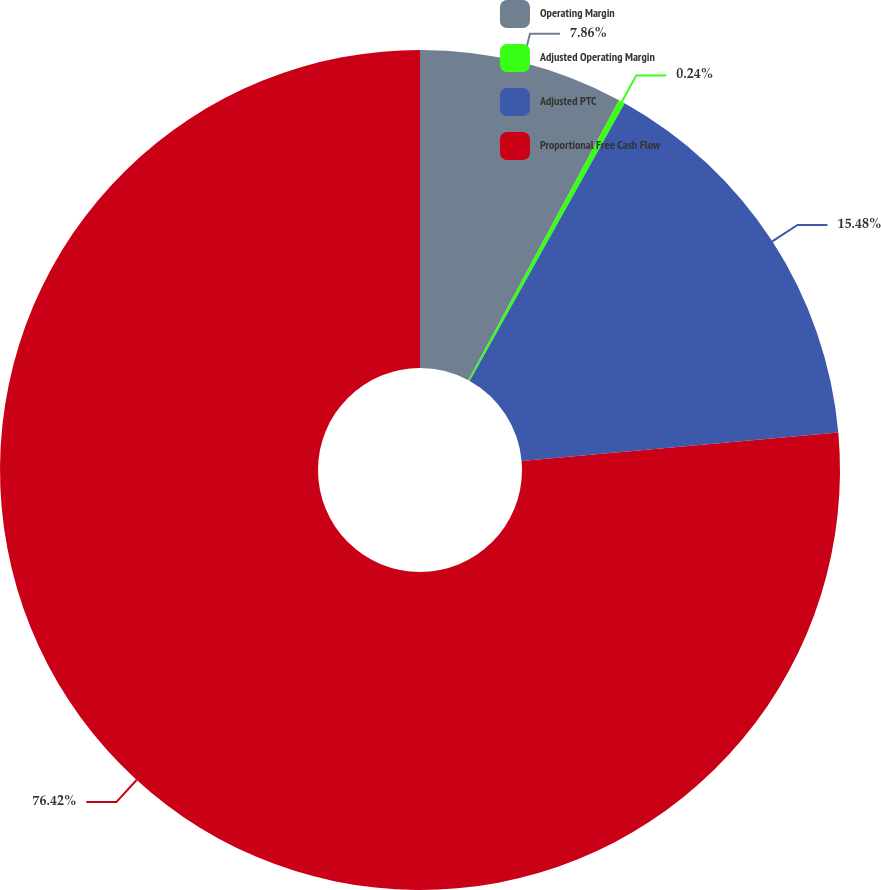Convert chart to OTSL. <chart><loc_0><loc_0><loc_500><loc_500><pie_chart><fcel>Operating Margin<fcel>Adjusted Operating Margin<fcel>Adjusted PTC<fcel>Proportional Free Cash Flow<nl><fcel>7.86%<fcel>0.24%<fcel>15.48%<fcel>76.43%<nl></chart> 